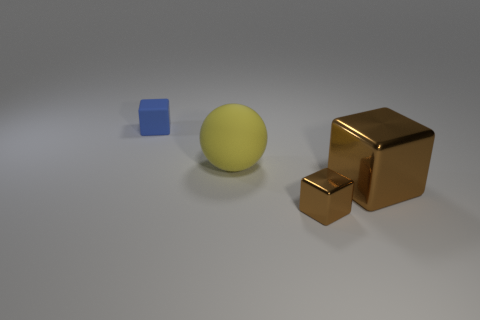How many objects are tiny objects that are in front of the small rubber object or small objects in front of the big brown shiny block?
Your response must be concise. 1. How many other things are the same color as the tiny rubber block?
Provide a short and direct response. 0. Are there fewer cubes behind the rubber block than large brown metallic blocks that are in front of the small brown metal block?
Keep it short and to the point. No. What number of yellow rubber balls are there?
Your answer should be very brief. 1. Is there any other thing that is made of the same material as the sphere?
Give a very brief answer. Yes. There is another big thing that is the same shape as the blue rubber thing; what is its material?
Give a very brief answer. Metal. Are there fewer yellow matte things that are in front of the sphere than large metallic objects?
Your answer should be compact. Yes. Do the large brown metal thing that is to the right of the matte sphere and the blue rubber object have the same shape?
Make the answer very short. Yes. Is there any other thing that is the same color as the sphere?
Give a very brief answer. No. There is a block that is the same material as the big brown object; what size is it?
Your answer should be compact. Small. 